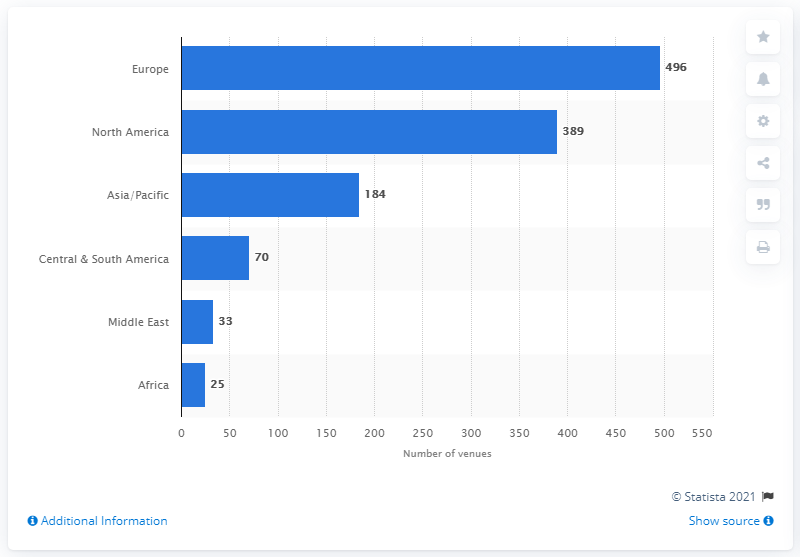Point out several critical features in this image. In 2011, there were 389 exhibition venues in North America. 